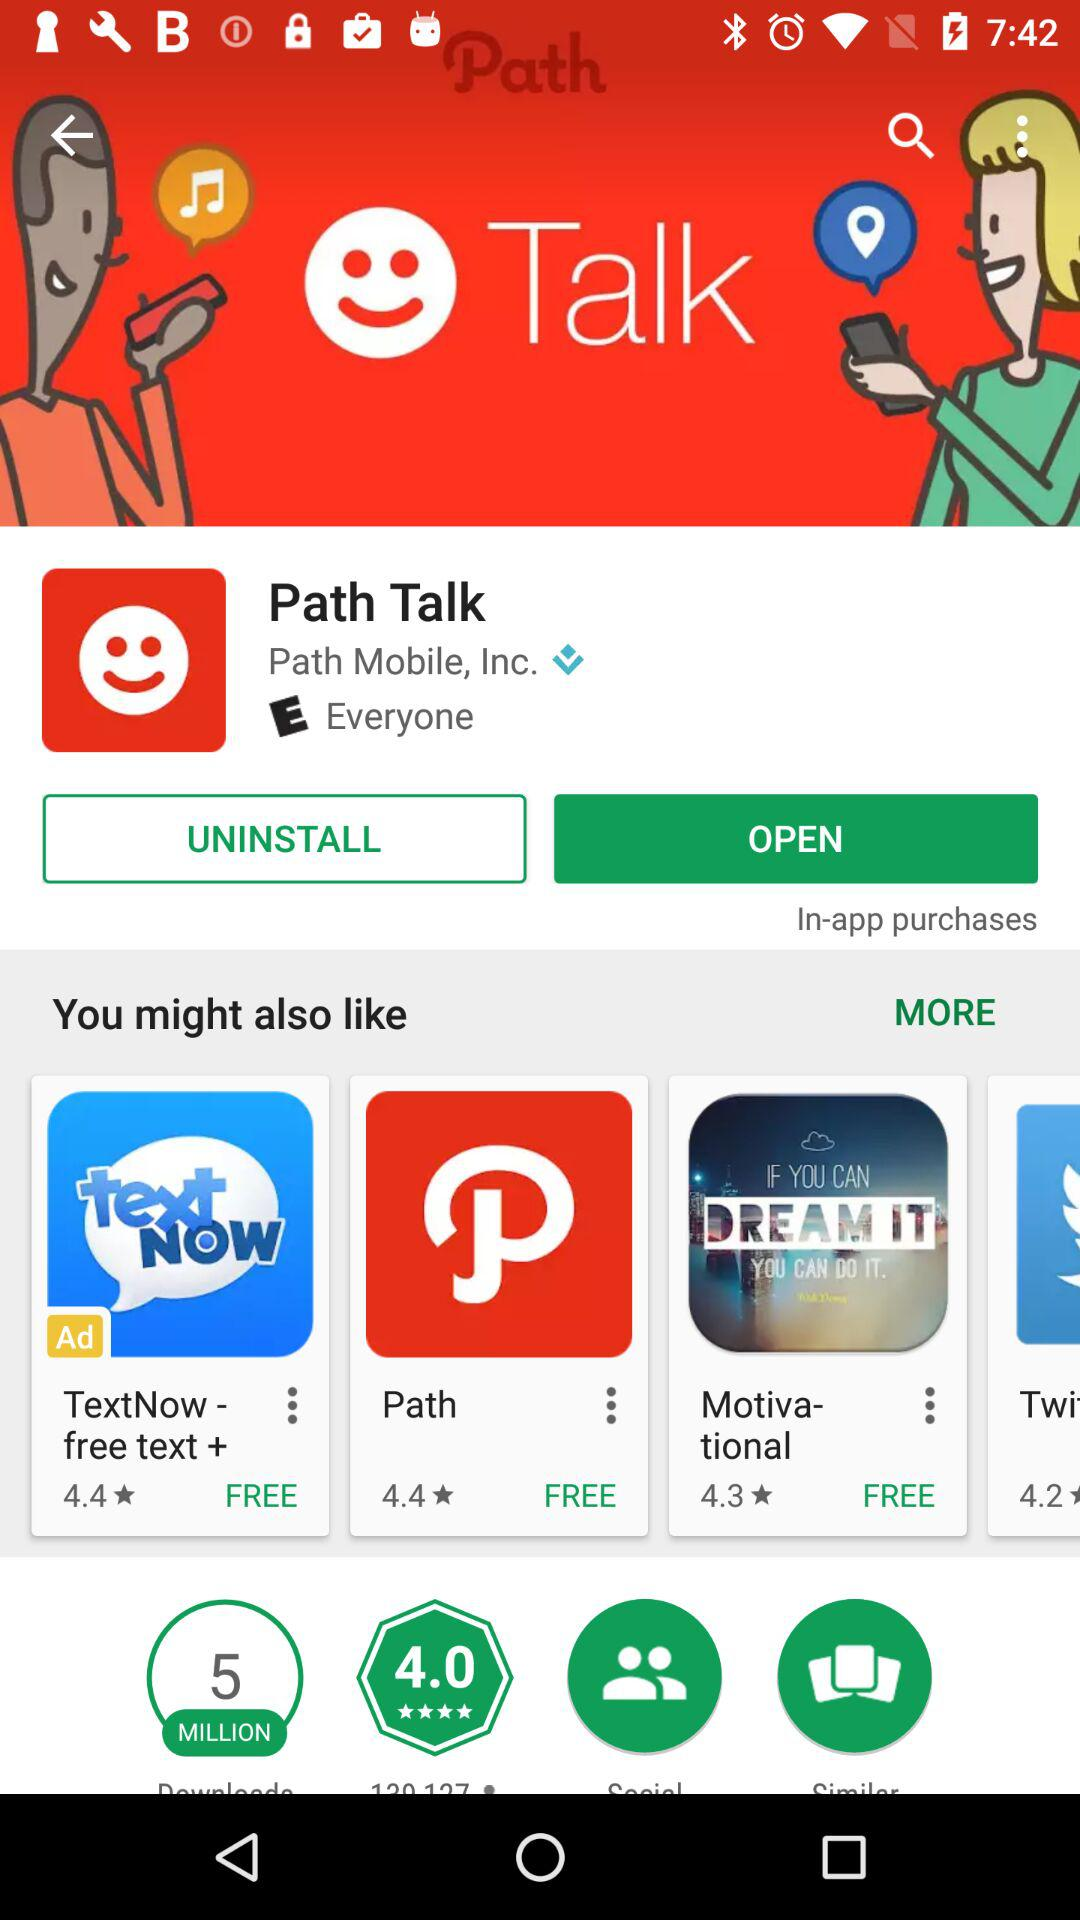What is the rating for the application? The rating is 4. 